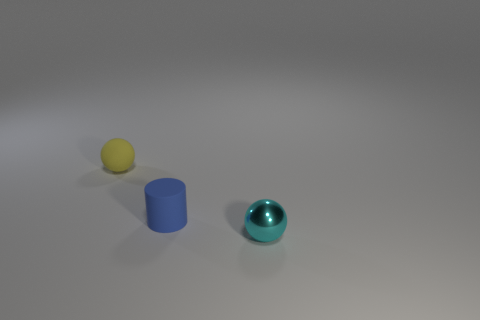Do the tiny metallic thing and the tiny rubber sphere have the same color?
Offer a terse response. No. What number of objects are right of the blue cylinder and to the left of the rubber cylinder?
Provide a short and direct response. 0. What number of metallic things are small yellow spheres or small purple spheres?
Make the answer very short. 0. What material is the object that is behind the matte object that is in front of the yellow sphere?
Keep it short and to the point. Rubber. The blue matte thing that is the same size as the cyan thing is what shape?
Offer a terse response. Cylinder. Are there fewer small rubber cylinders than large brown cubes?
Your answer should be compact. No. There is a sphere to the right of the rubber cylinder; is there a small ball that is right of it?
Your response must be concise. No. There is a yellow thing that is made of the same material as the cylinder; what is its shape?
Give a very brief answer. Sphere. Are there any other things that are the same color as the cylinder?
Your response must be concise. No. There is another thing that is the same shape as the metal thing; what is it made of?
Offer a very short reply. Rubber. 